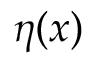Convert formula to latex. <formula><loc_0><loc_0><loc_500><loc_500>\eta ( x )</formula> 